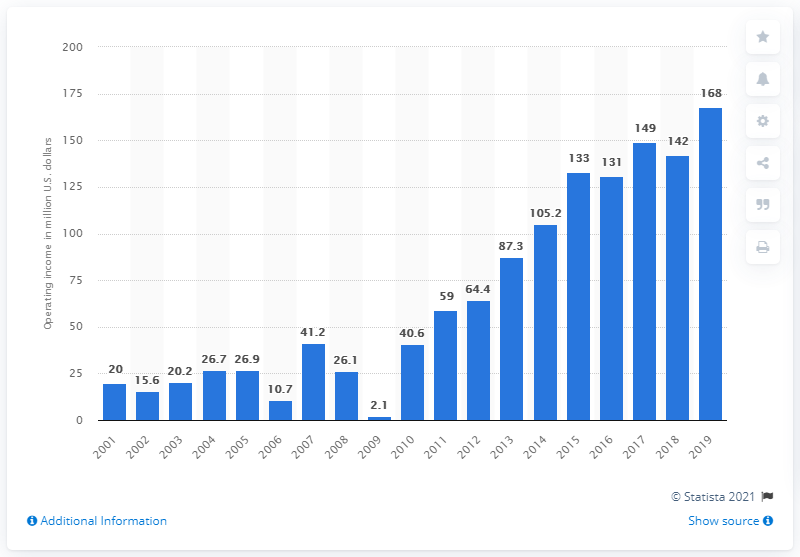List a handful of essential elements in this visual. The operating income of the New York Giants in the 2019 season was 168. 